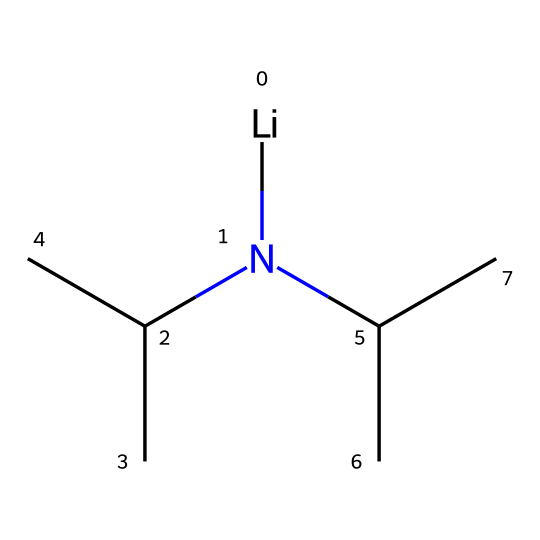How many carbon atoms are in lithium diisopropylamide? The SMILES representation indicates two isopropyl groups (C(C)C) connected to the nitrogen atom and one carbon atom for the lithium. Hence, there are 6 carbon atoms in total (2 from each isopropyl group).
Answer: six What is the central atom in lithium diisopropylamide? The central atom in this molecule is nitrogen (N), as it is directly bonded to lithium and the two isopropyl groups.
Answer: nitrogen How many isopropyl groups are present in lithium diisopropylamide? The SMILES structure shows two instances of the isopropyl group (C(C)C), which are attached to the nitrogen atom.
Answer: two What is the coordination number of lithium in lithium diisopropylamide? In this structure, lithium (Li) is connected only to the nitrogen atom, giving it a coordination number of 1.
Answer: one Is lithium diisopropylamide a base? Given its structure and presence of the nitrogen with lone pairs, LDA acts as a strong base, especially in non-protic solvents.
Answer: yes Which functional group is primarily responsible for the basicity of lithium diisopropylamide? The nitrogen atom, connected to the lithium and the isopropyl groups, holds lone pairs that can readily accept protons, enhancing its basicity.
Answer: nitrogen 